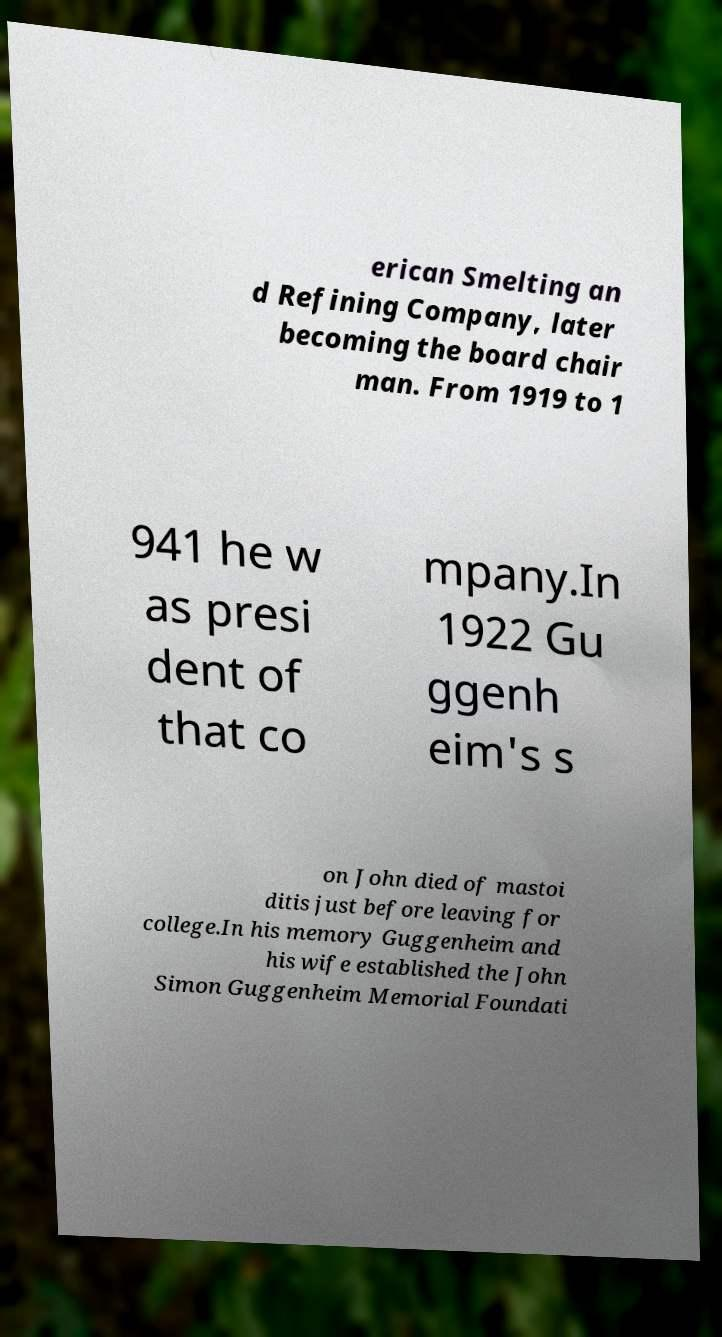Could you extract and type out the text from this image? erican Smelting an d Refining Company, later becoming the board chair man. From 1919 to 1 941 he w as presi dent of that co mpany.In 1922 Gu ggenh eim's s on John died of mastoi ditis just before leaving for college.In his memory Guggenheim and his wife established the John Simon Guggenheim Memorial Foundati 